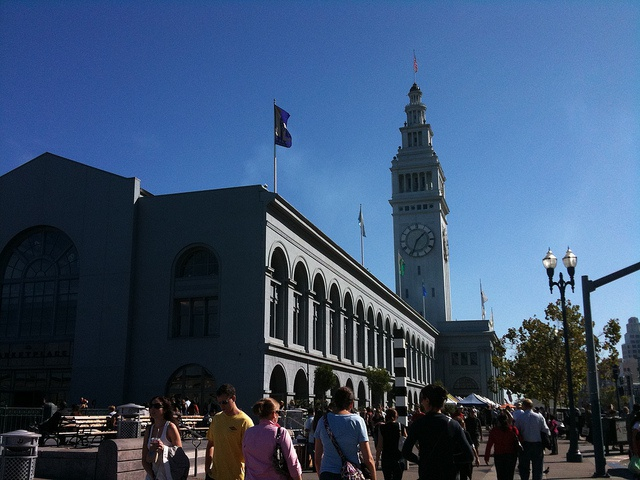Describe the objects in this image and their specific colors. I can see people in darkblue, black, gray, darkgray, and maroon tones, people in darkblue, black, and gray tones, people in darkblue, black, navy, gray, and maroon tones, people in darkblue, black, and purple tones, and people in darkblue, black, maroon, and khaki tones in this image. 